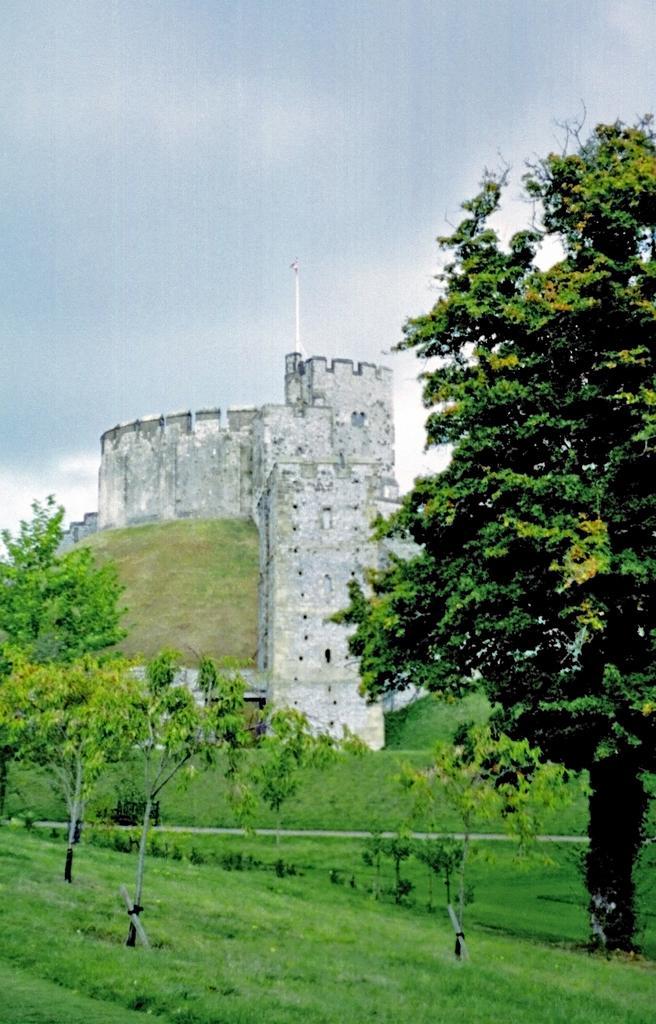Describe this image in one or two sentences. In this image, I can see the trees with branches and leaves. This is the grass. This looks like a building. Here is the sky. 